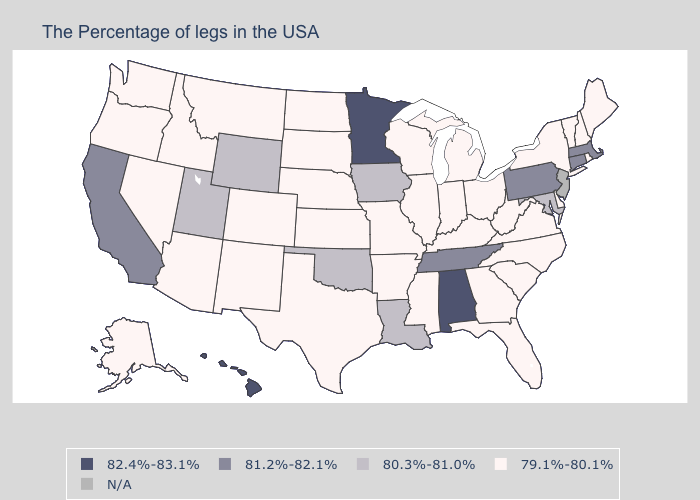What is the lowest value in states that border Utah?
Be succinct. 79.1%-80.1%. What is the lowest value in the West?
Be succinct. 79.1%-80.1%. What is the highest value in the USA?
Be succinct. 82.4%-83.1%. Among the states that border Illinois , does Missouri have the lowest value?
Keep it brief. Yes. What is the value of Connecticut?
Be succinct. 81.2%-82.1%. How many symbols are there in the legend?
Write a very short answer. 5. Does Wyoming have the highest value in the USA?
Keep it brief. No. Name the states that have a value in the range N/A?
Concise answer only. New Jersey. Does Minnesota have the lowest value in the MidWest?
Quick response, please. No. Among the states that border Oregon , does California have the lowest value?
Write a very short answer. No. What is the highest value in the Northeast ?
Write a very short answer. 81.2%-82.1%. Which states have the lowest value in the MidWest?
Short answer required. Ohio, Michigan, Indiana, Wisconsin, Illinois, Missouri, Kansas, Nebraska, South Dakota, North Dakota. Does the first symbol in the legend represent the smallest category?
Write a very short answer. No. Which states have the highest value in the USA?
Be succinct. Alabama, Minnesota, Hawaii. 